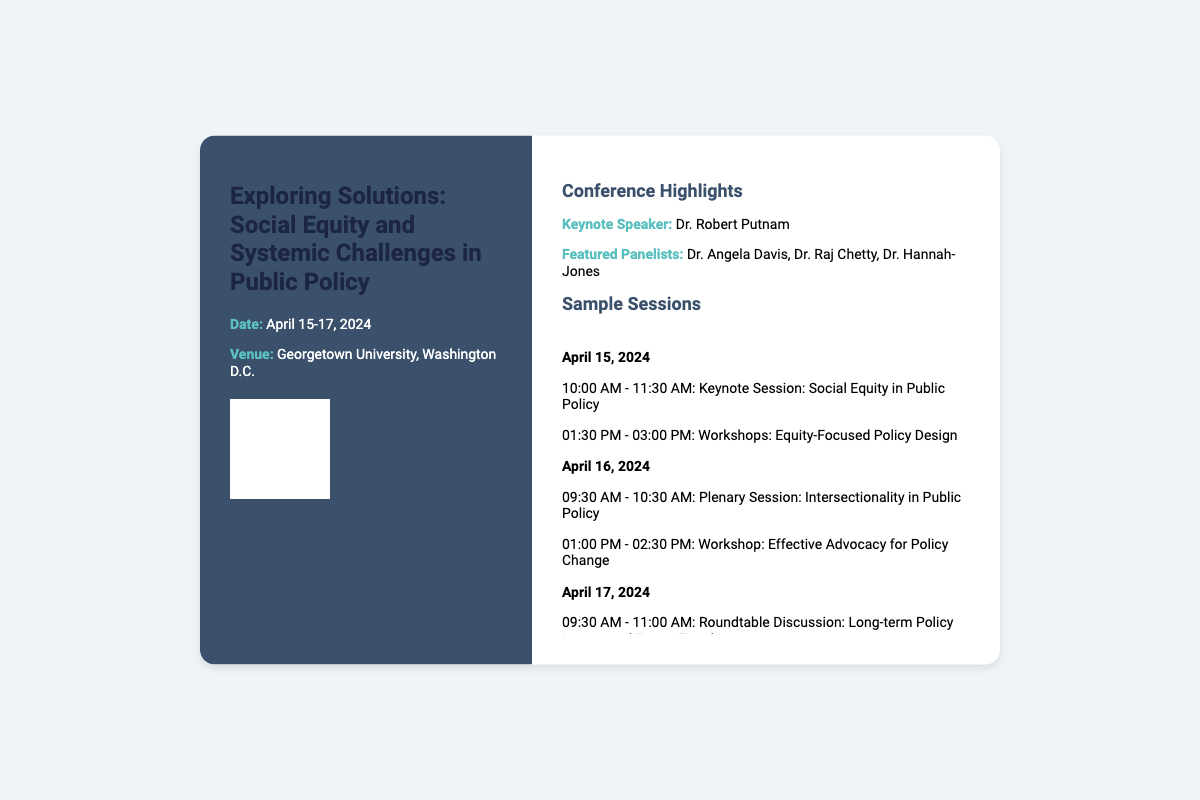What are the dates of the conference? The dates of the conference are specified as April 15-17, 2024.
Answer: April 15-17, 2024 Who is the keynote speaker? The name of the keynote speaker is found in the "Conference Highlights" section.
Answer: Dr. Robert Putnam What is the venue for the conference? The venue is mentioned in the opening section of the ticket.
Answer: Georgetown University, Washington D.C What is one of the workshop topics on April 15? The ticket lists workshop topics and their dates; one can be retrieved from April 15's schedule.
Answer: Equity-Focused Policy Design What time does the roundtable discussion start on April 17? The start time for the roundtable discussion is indicated in the schedule for April 17.
Answer: 09:30 AM Which panelist is known for their work on intersectionality? The document lists featured panelists, and reasoning is used to match the right person to the topic.
Answer: Dr. Angela Davis What session concludes the conference? The concluding session is detailed at the end of April 17's schedule.
Answer: Concluding Remarks and Future Directions How long is the keynote session on April 15? The duration of the keynote session can be deduced from the time range given in the schedule.
Answer: 1.5 hours What is the theme of the conference? The theme is articulated in the title of the ticket itself.
Answer: Social Equity and Systemic Challenges in Public Policy 